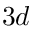<formula> <loc_0><loc_0><loc_500><loc_500>3 d</formula> 